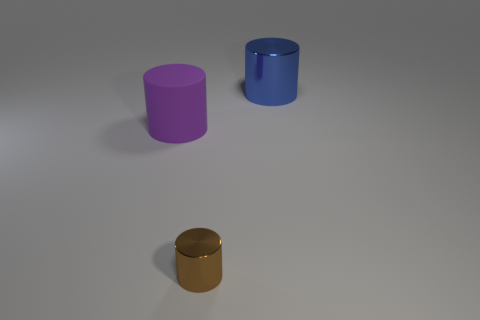Subtract all tiny brown cylinders. How many cylinders are left? 2 Add 1 big blue blocks. How many objects exist? 4 Add 2 large objects. How many large objects are left? 4 Add 1 tiny cyan rubber things. How many tiny cyan rubber things exist? 1 Subtract 0 yellow cylinders. How many objects are left? 3 Subtract all large blue shiny things. Subtract all blue metallic things. How many objects are left? 1 